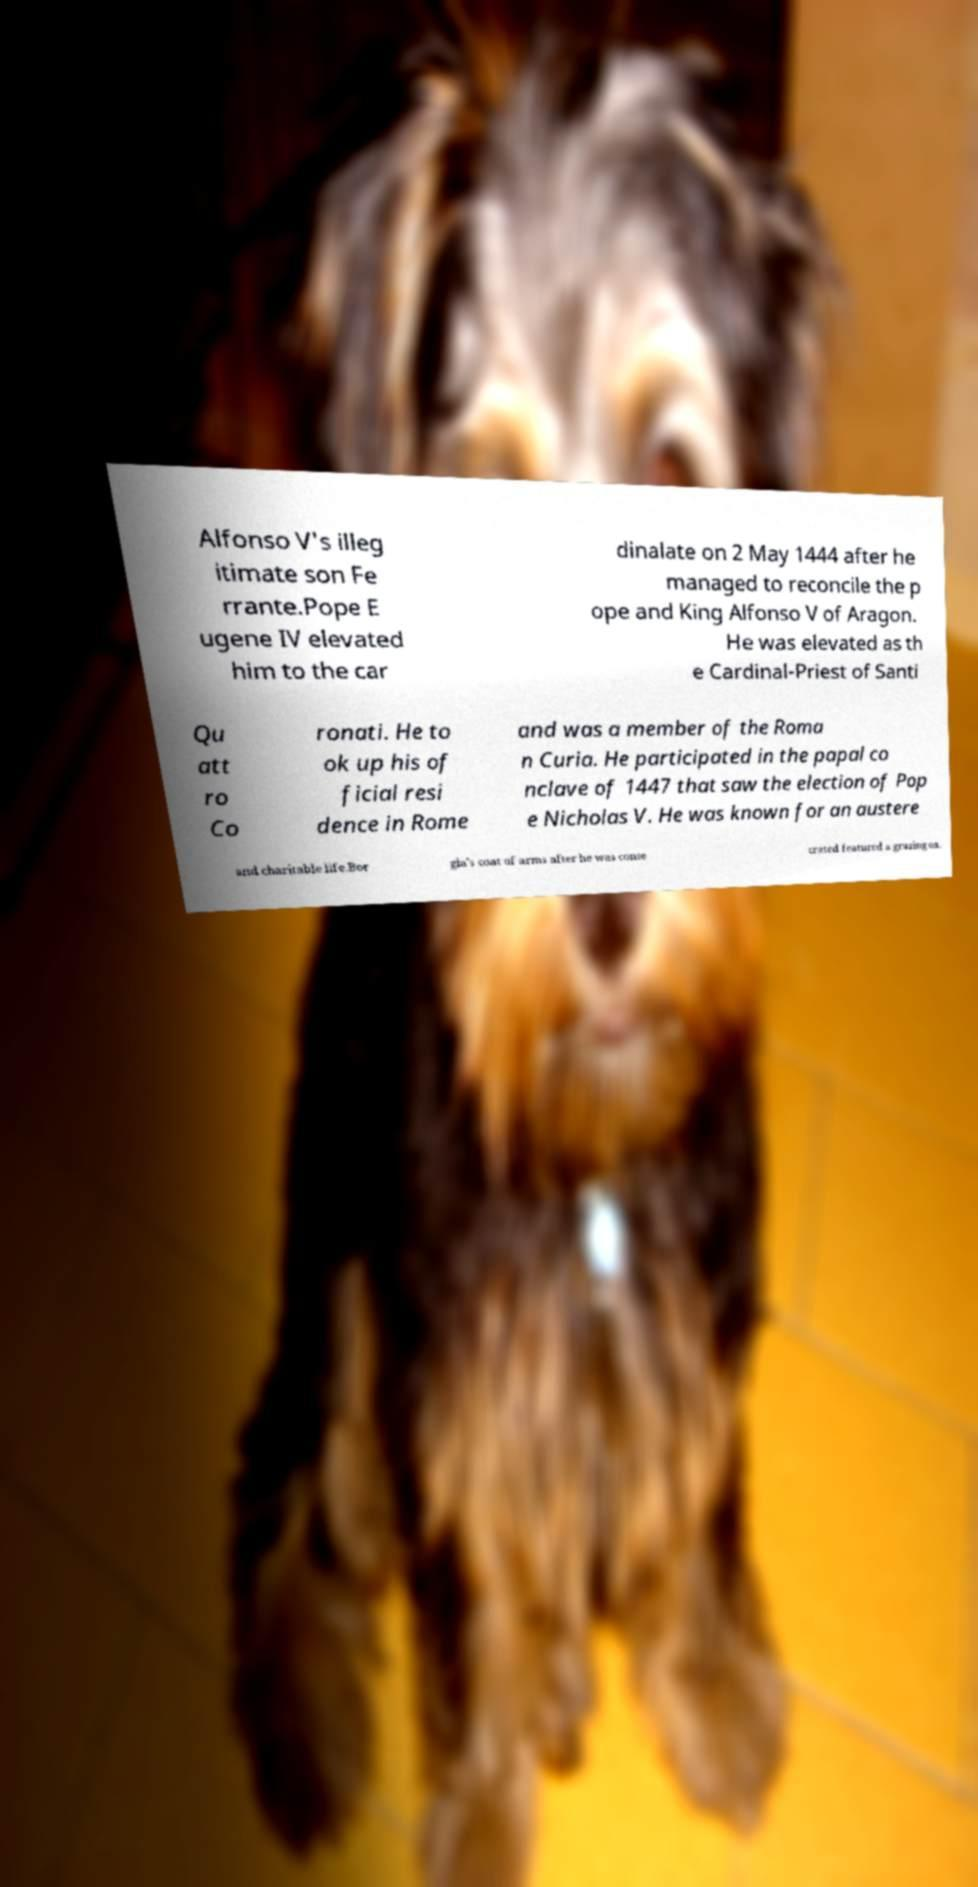What messages or text are displayed in this image? I need them in a readable, typed format. Alfonso V's illeg itimate son Fe rrante.Pope E ugene IV elevated him to the car dinalate on 2 May 1444 after he managed to reconcile the p ope and King Alfonso V of Aragon. He was elevated as th e Cardinal-Priest of Santi Qu att ro Co ronati. He to ok up his of ficial resi dence in Rome and was a member of the Roma n Curia. He participated in the papal co nclave of 1447 that saw the election of Pop e Nicholas V. He was known for an austere and charitable life.Bor gia's coat of arms after he was conse crated featured a grazing ox. 